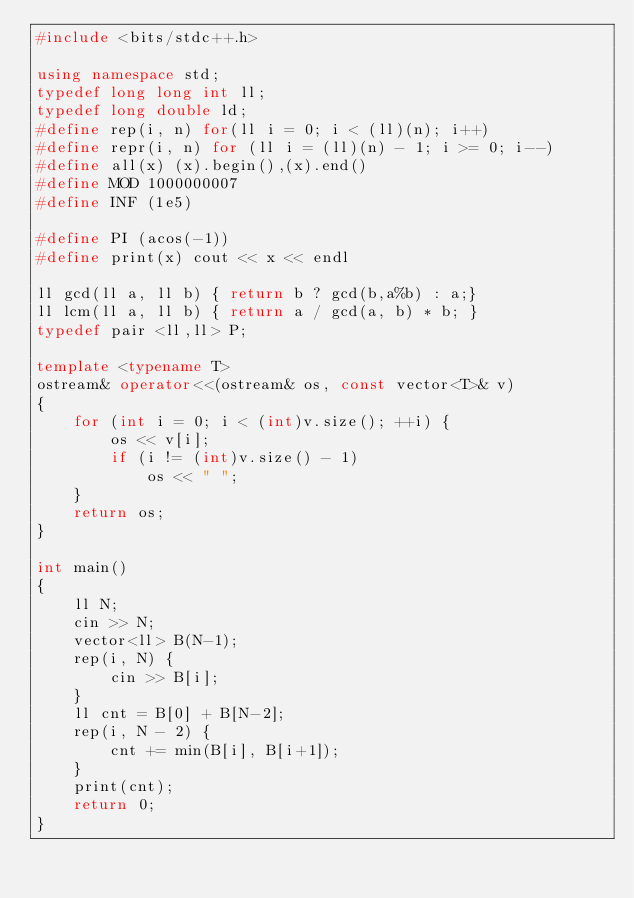Convert code to text. <code><loc_0><loc_0><loc_500><loc_500><_C++_>#include <bits/stdc++.h>
 
using namespace std;
typedef long long int ll;
typedef long double ld;
#define rep(i, n) for(ll i = 0; i < (ll)(n); i++)
#define repr(i, n) for (ll i = (ll)(n) - 1; i >= 0; i--)
#define all(x) (x).begin(),(x).end()
#define MOD 1000000007
#define INF (1e5)

#define PI (acos(-1))
#define print(x) cout << x << endl
 
ll gcd(ll a, ll b) { return b ? gcd(b,a%b) : a;}
ll lcm(ll a, ll b) { return a / gcd(a, b) * b; }
typedef pair <ll,ll> P;

template <typename T> 
ostream& operator<<(ostream& os, const vector<T>& v) 
{ 
    for (int i = 0; i < (int)v.size(); ++i) { 
        os << v[i]; 
        if (i != (int)v.size() - 1) 
            os << " "; 
    } 
    return os; 
} 

int main()
{
    ll N;
    cin >> N;
    vector<ll> B(N-1);
    rep(i, N) { 
        cin >> B[i];
    }
    ll cnt = B[0] + B[N-2];
    rep(i, N - 2) {
        cnt += min(B[i], B[i+1]);
    }
    print(cnt);
    return 0;
}</code> 